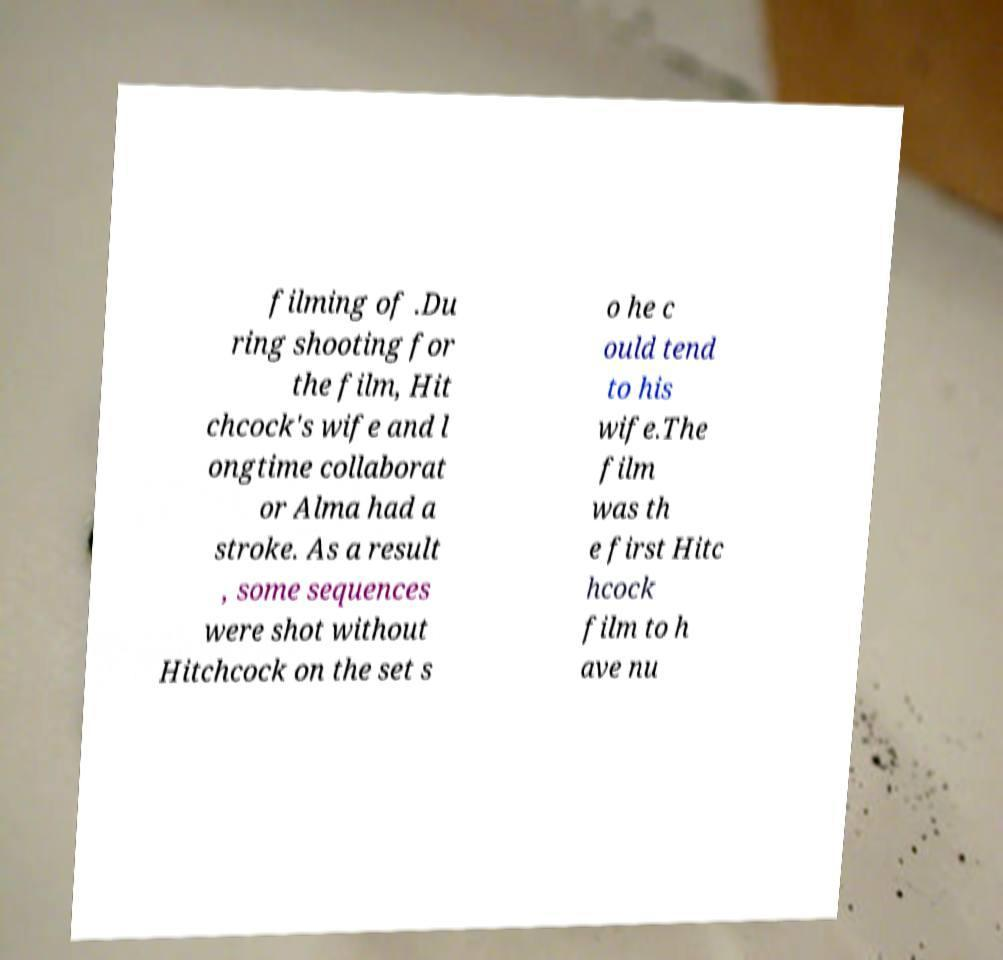Can you read and provide the text displayed in the image?This photo seems to have some interesting text. Can you extract and type it out for me? filming of .Du ring shooting for the film, Hit chcock's wife and l ongtime collaborat or Alma had a stroke. As a result , some sequences were shot without Hitchcock on the set s o he c ould tend to his wife.The film was th e first Hitc hcock film to h ave nu 